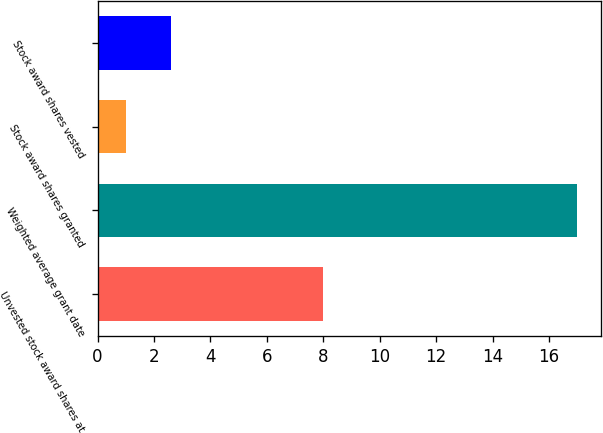Convert chart to OTSL. <chart><loc_0><loc_0><loc_500><loc_500><bar_chart><fcel>Unvested stock award shares at<fcel>Weighted average grant date<fcel>Stock award shares granted<fcel>Stock award shares vested<nl><fcel>8<fcel>17<fcel>1<fcel>2.6<nl></chart> 